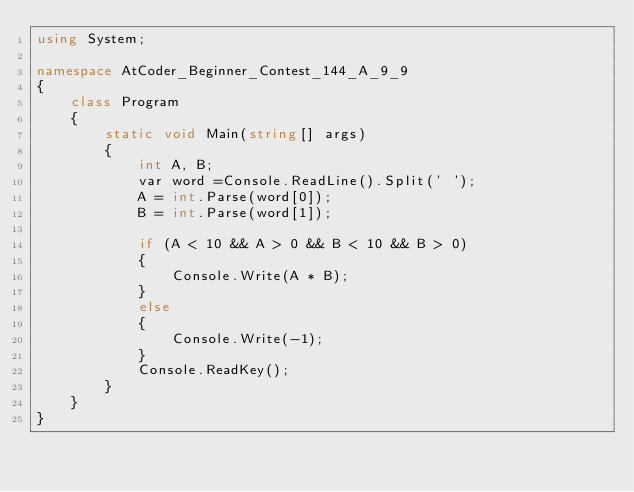<code> <loc_0><loc_0><loc_500><loc_500><_C#_>using System;

namespace AtCoder_Beginner_Contest_144_A_9_9
{
    class Program
    {
        static void Main(string[] args)
        {
            int A, B;
            var word =Console.ReadLine().Split(' ');
            A = int.Parse(word[0]);
            B = int.Parse(word[1]);
           
            if (A < 10 && A > 0 && B < 10 && B > 0)
            {
                Console.Write(A * B);
            }
            else
            { 
                Console.Write(-1);
            }
            Console.ReadKey();
        }
    }
}
</code> 